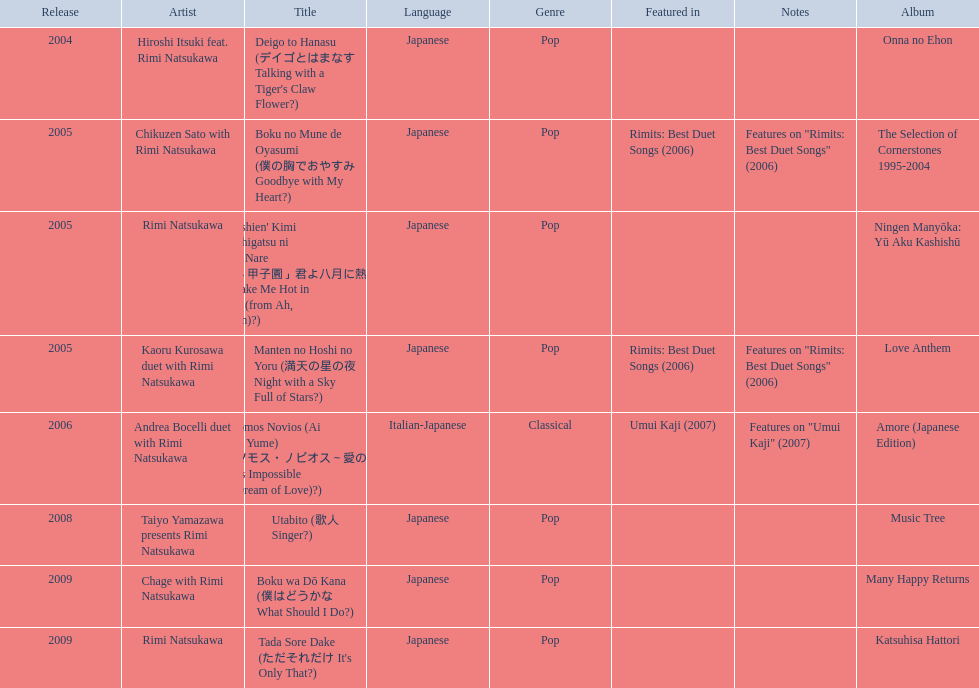What are the names of each album by rimi natsukawa? Onna no Ehon, The Selection of Cornerstones 1995-2004, Ningen Manyōka: Yū Aku Kashishū, Love Anthem, Amore (Japanese Edition), Music Tree, Many Happy Returns, Katsuhisa Hattori. And when were the albums released? 2004, 2005, 2005, 2005, 2006, 2008, 2009, 2009. Was onna no ehon or music tree released most recently? Music Tree. 